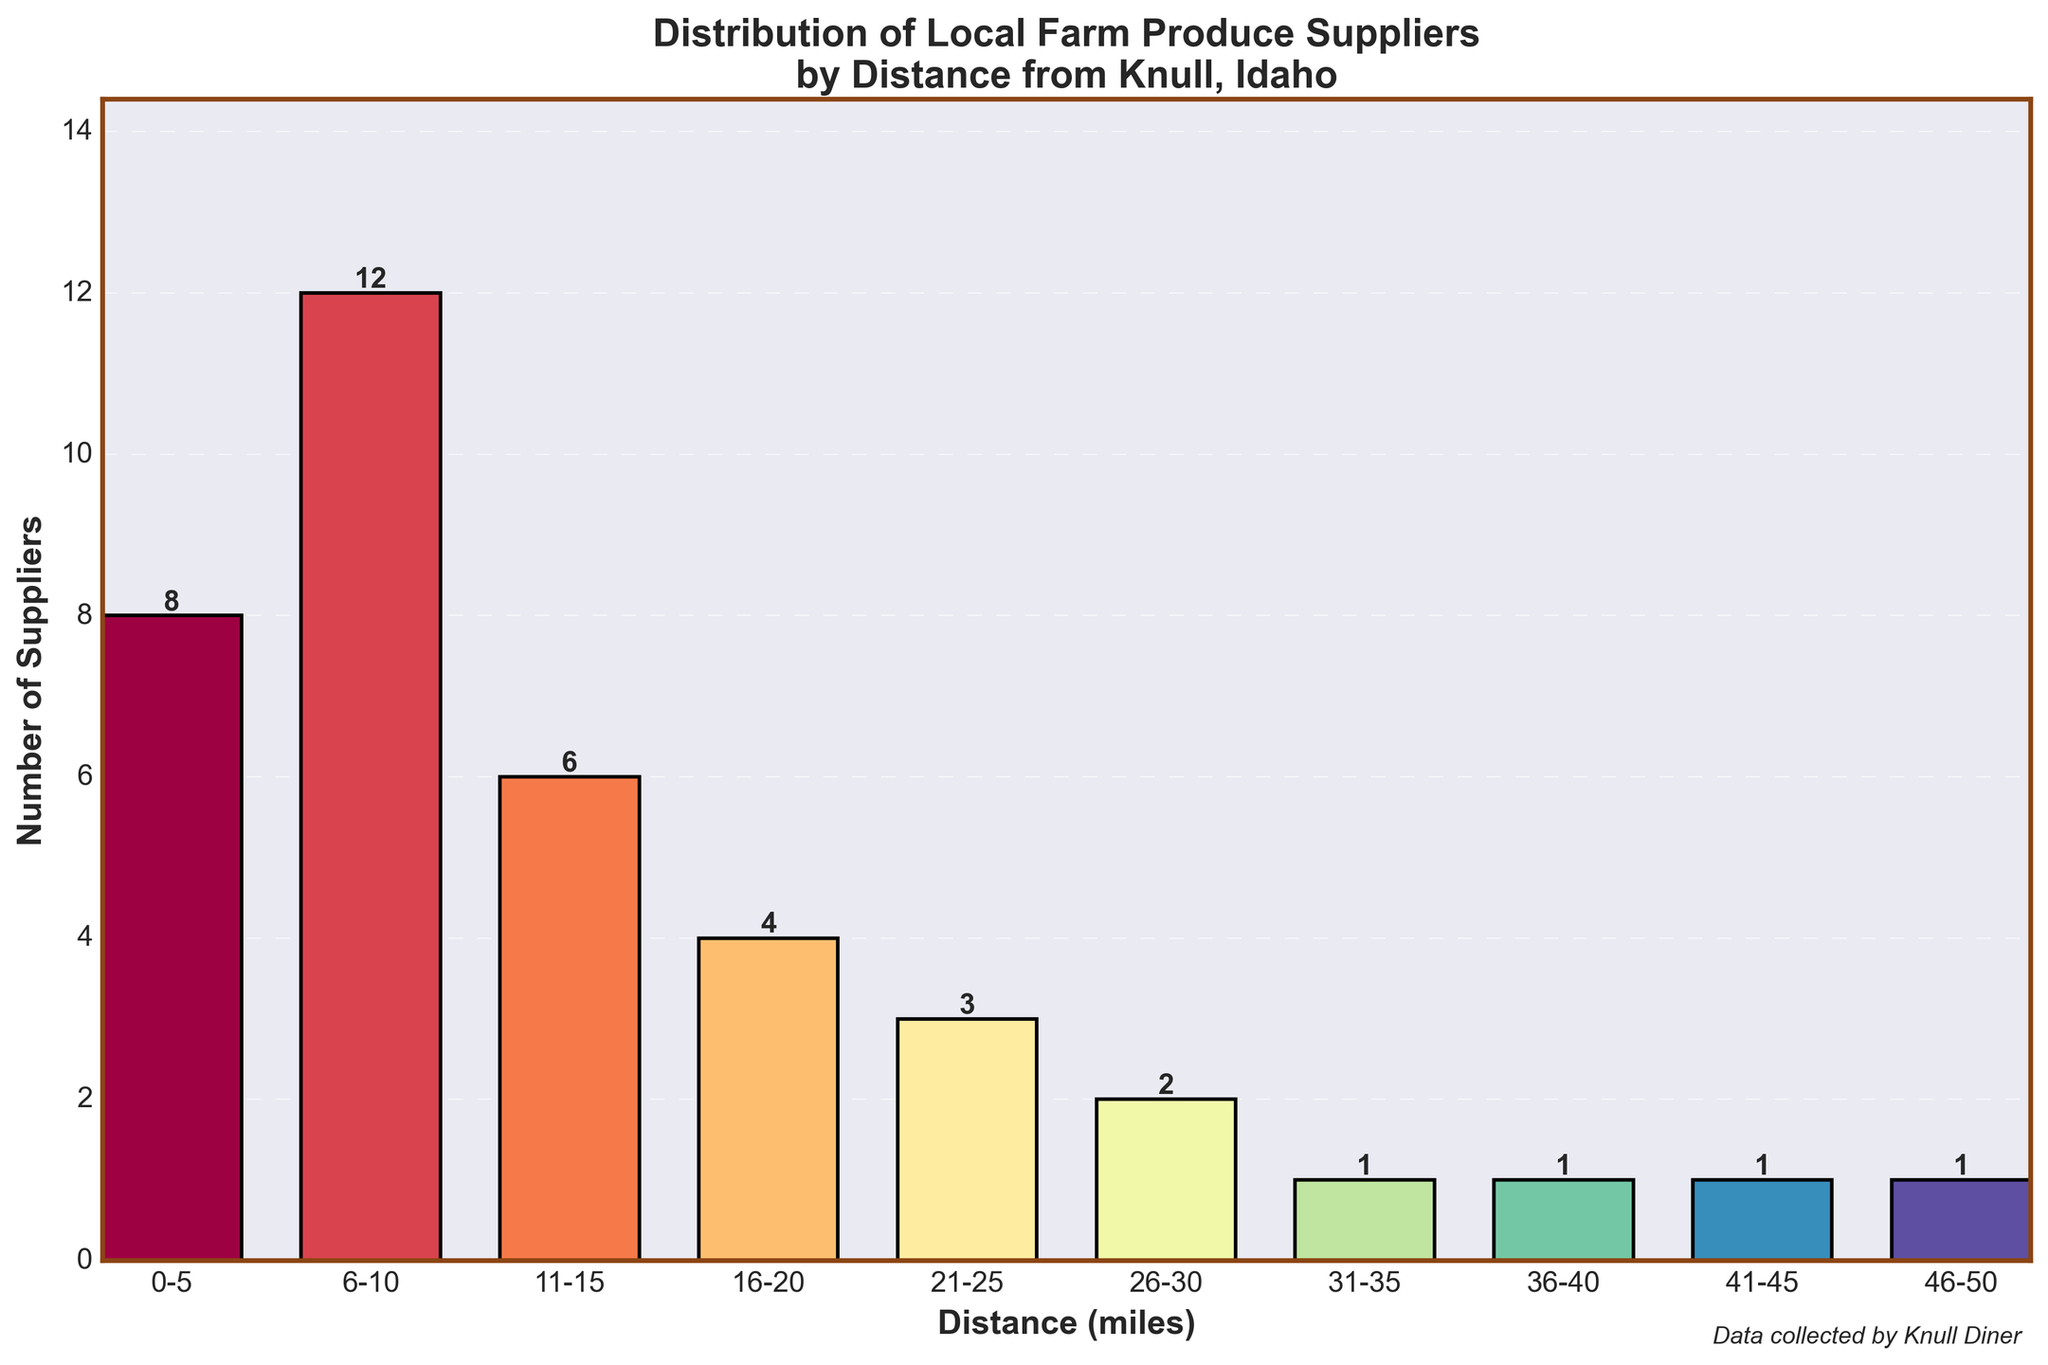What is the total number of local farm produce suppliers within 10 miles of Knull, Idaho? Sum the number of suppliers in the 0-5 mile and 6-10 mile ranges: 8 + 12 = 20
Answer: 20 Which distance range has the highest number of suppliers? The bar corresponding to the 6-10 mile range is the tallest, indicating the highest number of suppliers.
Answer: 6-10 miles How many more suppliers are there in the 6-10 mile range compared to the 16-20 mile range? Subtract the number of suppliers in the 16-20 mile range from the number in the 6-10 mile range: 12 - 4 = 8
Answer: 8 What is the average number of suppliers across all distance ranges? Sum totals of suppliers and divide by the number of ranges: (8 + 12 + 6 + 4 + 3 + 2 + 1 + 1 + 1 + 1) / 10 = 39 / 10 = 3.9
Answer: 3.9 Are there any distance ranges with exactly the same number of suppliers? The ranges 31-35 miles, 36-40 miles, 41-45 miles, and 46-50 miles all have 1 supplier each.
Answer: Yes How many suppliers are there beyond 20 miles? Sum the number of suppliers from all ranges beyond 20 miles: 3 + 2 + 1 + 1 + 1 + 1 = 9
Answer: 9 Which distance ranges have the lowest number of suppliers, and how many are there in each? The distance ranges 31-35 miles, 36-40 miles, 41-45 miles, and 46-50 miles have the lowest number of suppliers with 1 each.
Answer: 31-35 miles, 36-40 miles, 41-45 miles, 46-50 miles; 1 each How much taller is the bar for the 6-10 mile range compared to the bar for the 11-15 mile range, visually? Based on the heights of the bars corresponding to these ranges, the 6-10 mile bar is visibly twice as tall as the 11-15 mile bar.
Answer: Twice as tall 